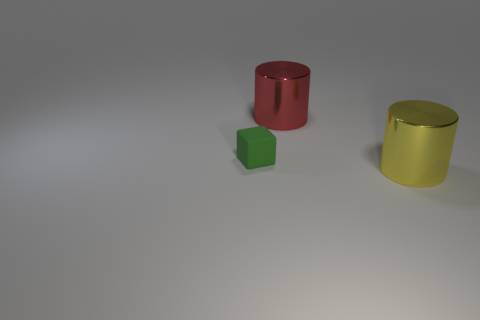Is there anything else that has the same material as the green thing?
Your answer should be very brief. No. Is there anything else that is the same size as the green object?
Your answer should be compact. No. There is a cylinder that is behind the big cylinder in front of the rubber block; are there any large cylinders that are in front of it?
Your response must be concise. Yes. How many other things are there of the same material as the small green thing?
Offer a terse response. 0. How many small red matte cubes are there?
Your answer should be compact. 0. How many things are large red cylinders or big cylinders behind the tiny green matte thing?
Offer a very short reply. 1. Are there any other things that have the same shape as the matte object?
Ensure brevity in your answer.  No. Does the cylinder right of the red thing have the same size as the red metal object?
Make the answer very short. Yes. How many shiny objects are small objects or red blocks?
Offer a very short reply. 0. There is a metal cylinder that is in front of the green rubber object; how big is it?
Give a very brief answer. Large. 